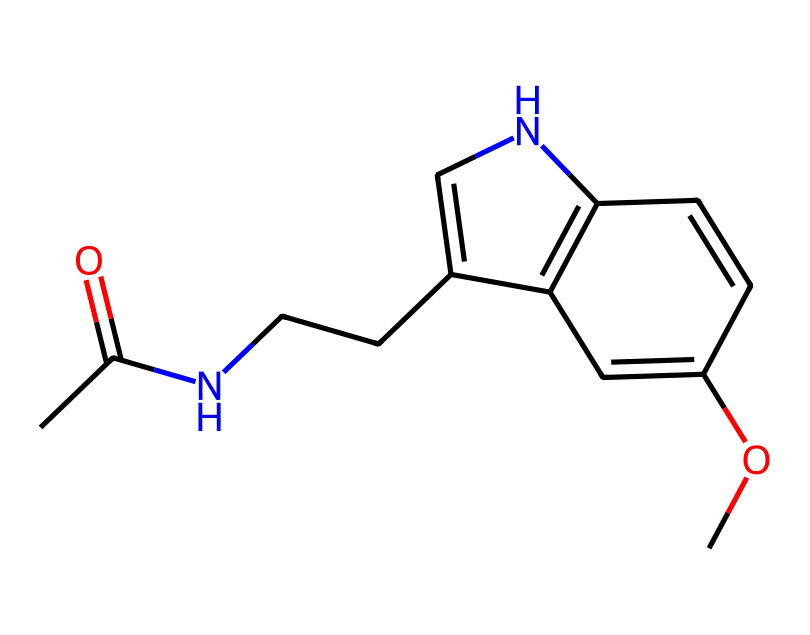What is the molecular formula of this compound? To determine the molecular formula, we need to count the number of each type of atom present in the SMILES representation. The compound contains:  10 Carbon (C), 13 Hydrogen (H), 1 Nitrogen (N), and 2 Oxygen (O) atoms. This gives us the molecular formula C13H16N2O2.
Answer: C13H16N2O2 How many double bonds are present in the structure? By analyzing the SMILES code, we can identify the double bond represented by "=", which indicates a double bond between the carbon atoms. In this structure, there is one double bond present.
Answer: 1 Which atoms are responsible for the non-electrolyte nature of melatonin? Non-electrolytes typically do not dissociate into ions in solution. In the chemical structure, the atoms seen in covalent bonds, predominantly carbon, hydrogen, nitrogen, and oxygen, do not contribute to ionic dissociation, making the entire structure non-electrolytic.
Answer: carbon, hydrogen, nitrogen, oxygen How many aromatic rings are present in the Chemical Structure? Aromatic rings are characterized by cyclic structures with delocalized pi-electrons, typically represented in SMILES by lowercase letters or connections. Analyzing the structure reveals that there is one distinct aromatic ring present in the molecule.
Answer: 1 What is the role of the nitrogen atom in this compound? In melatonin, the nitrogen atom is part of an amine functional group which can influence the molecule's biological activity, particularly in binding to receptors and therefore affecting sleep regulation.
Answer: amine functional group 